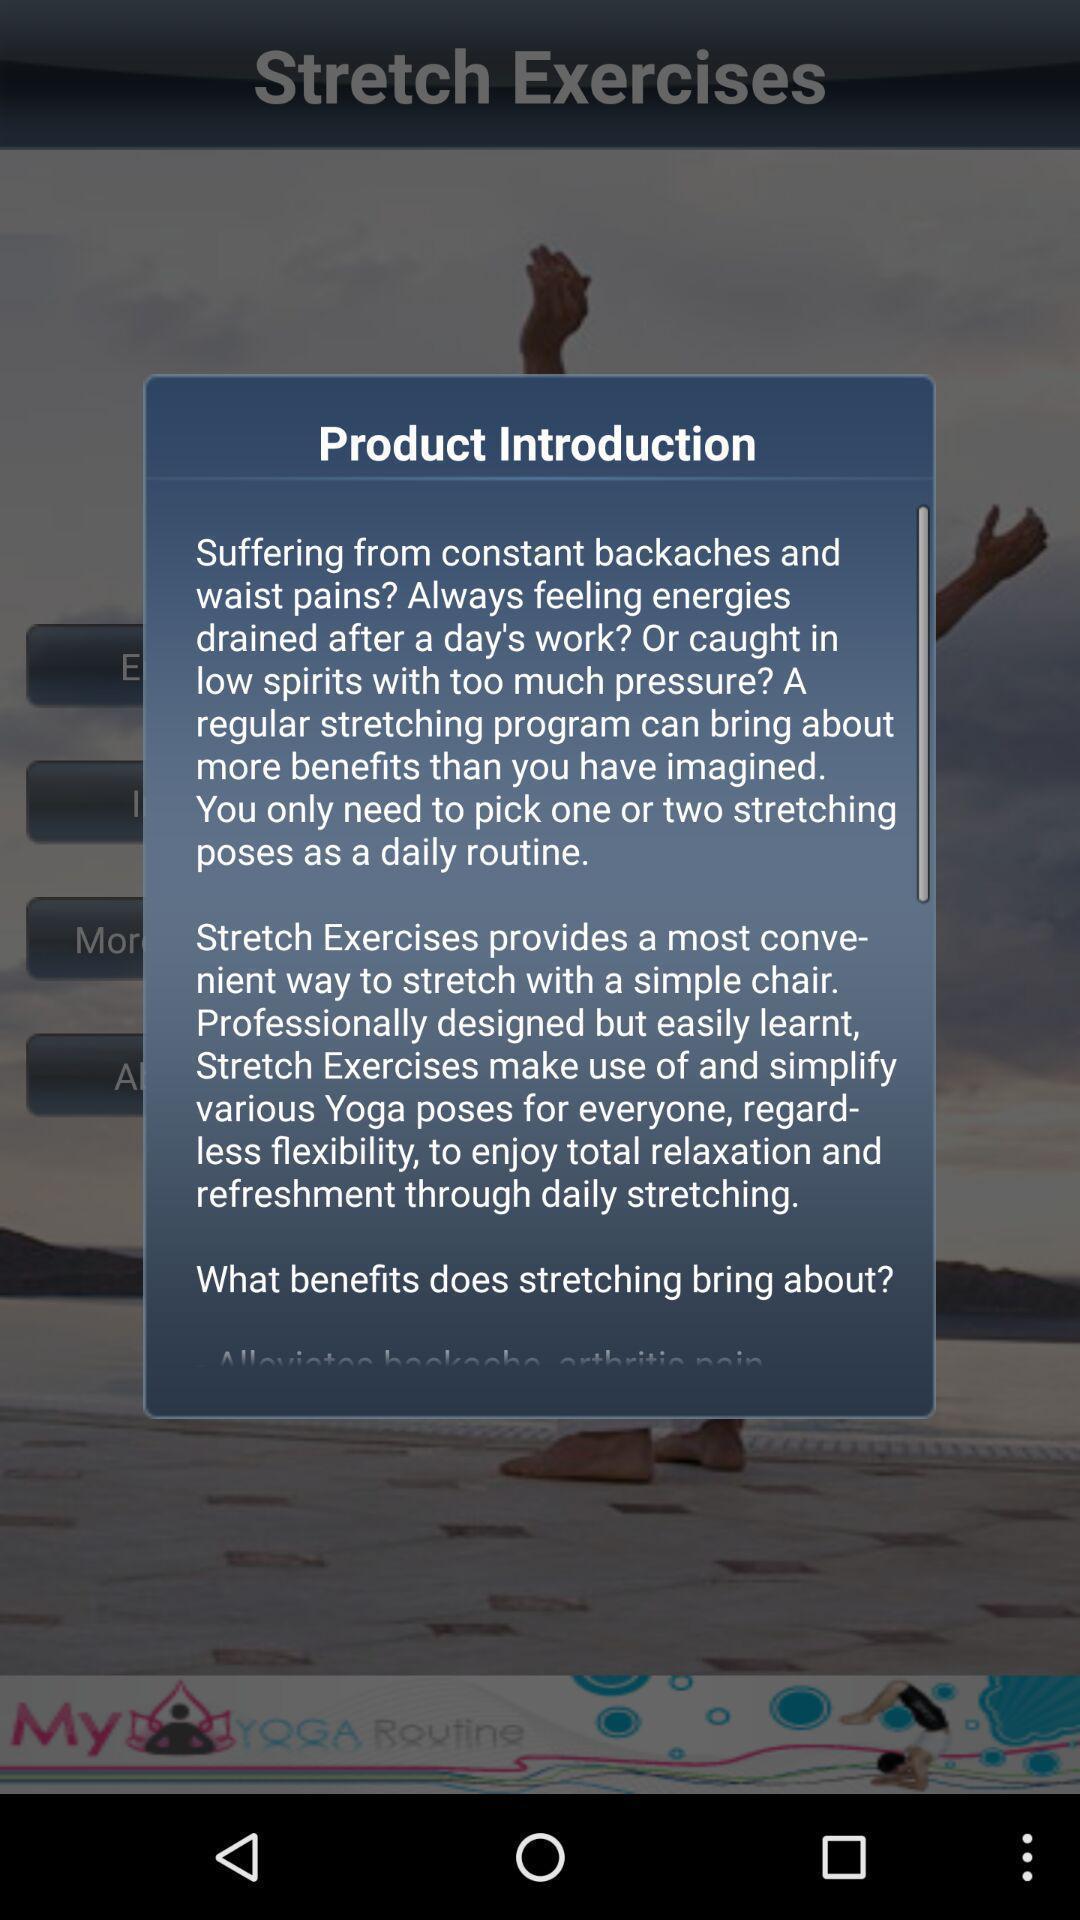Explain the elements present in this screenshot. Pop-up shows product details in a fitness app. 